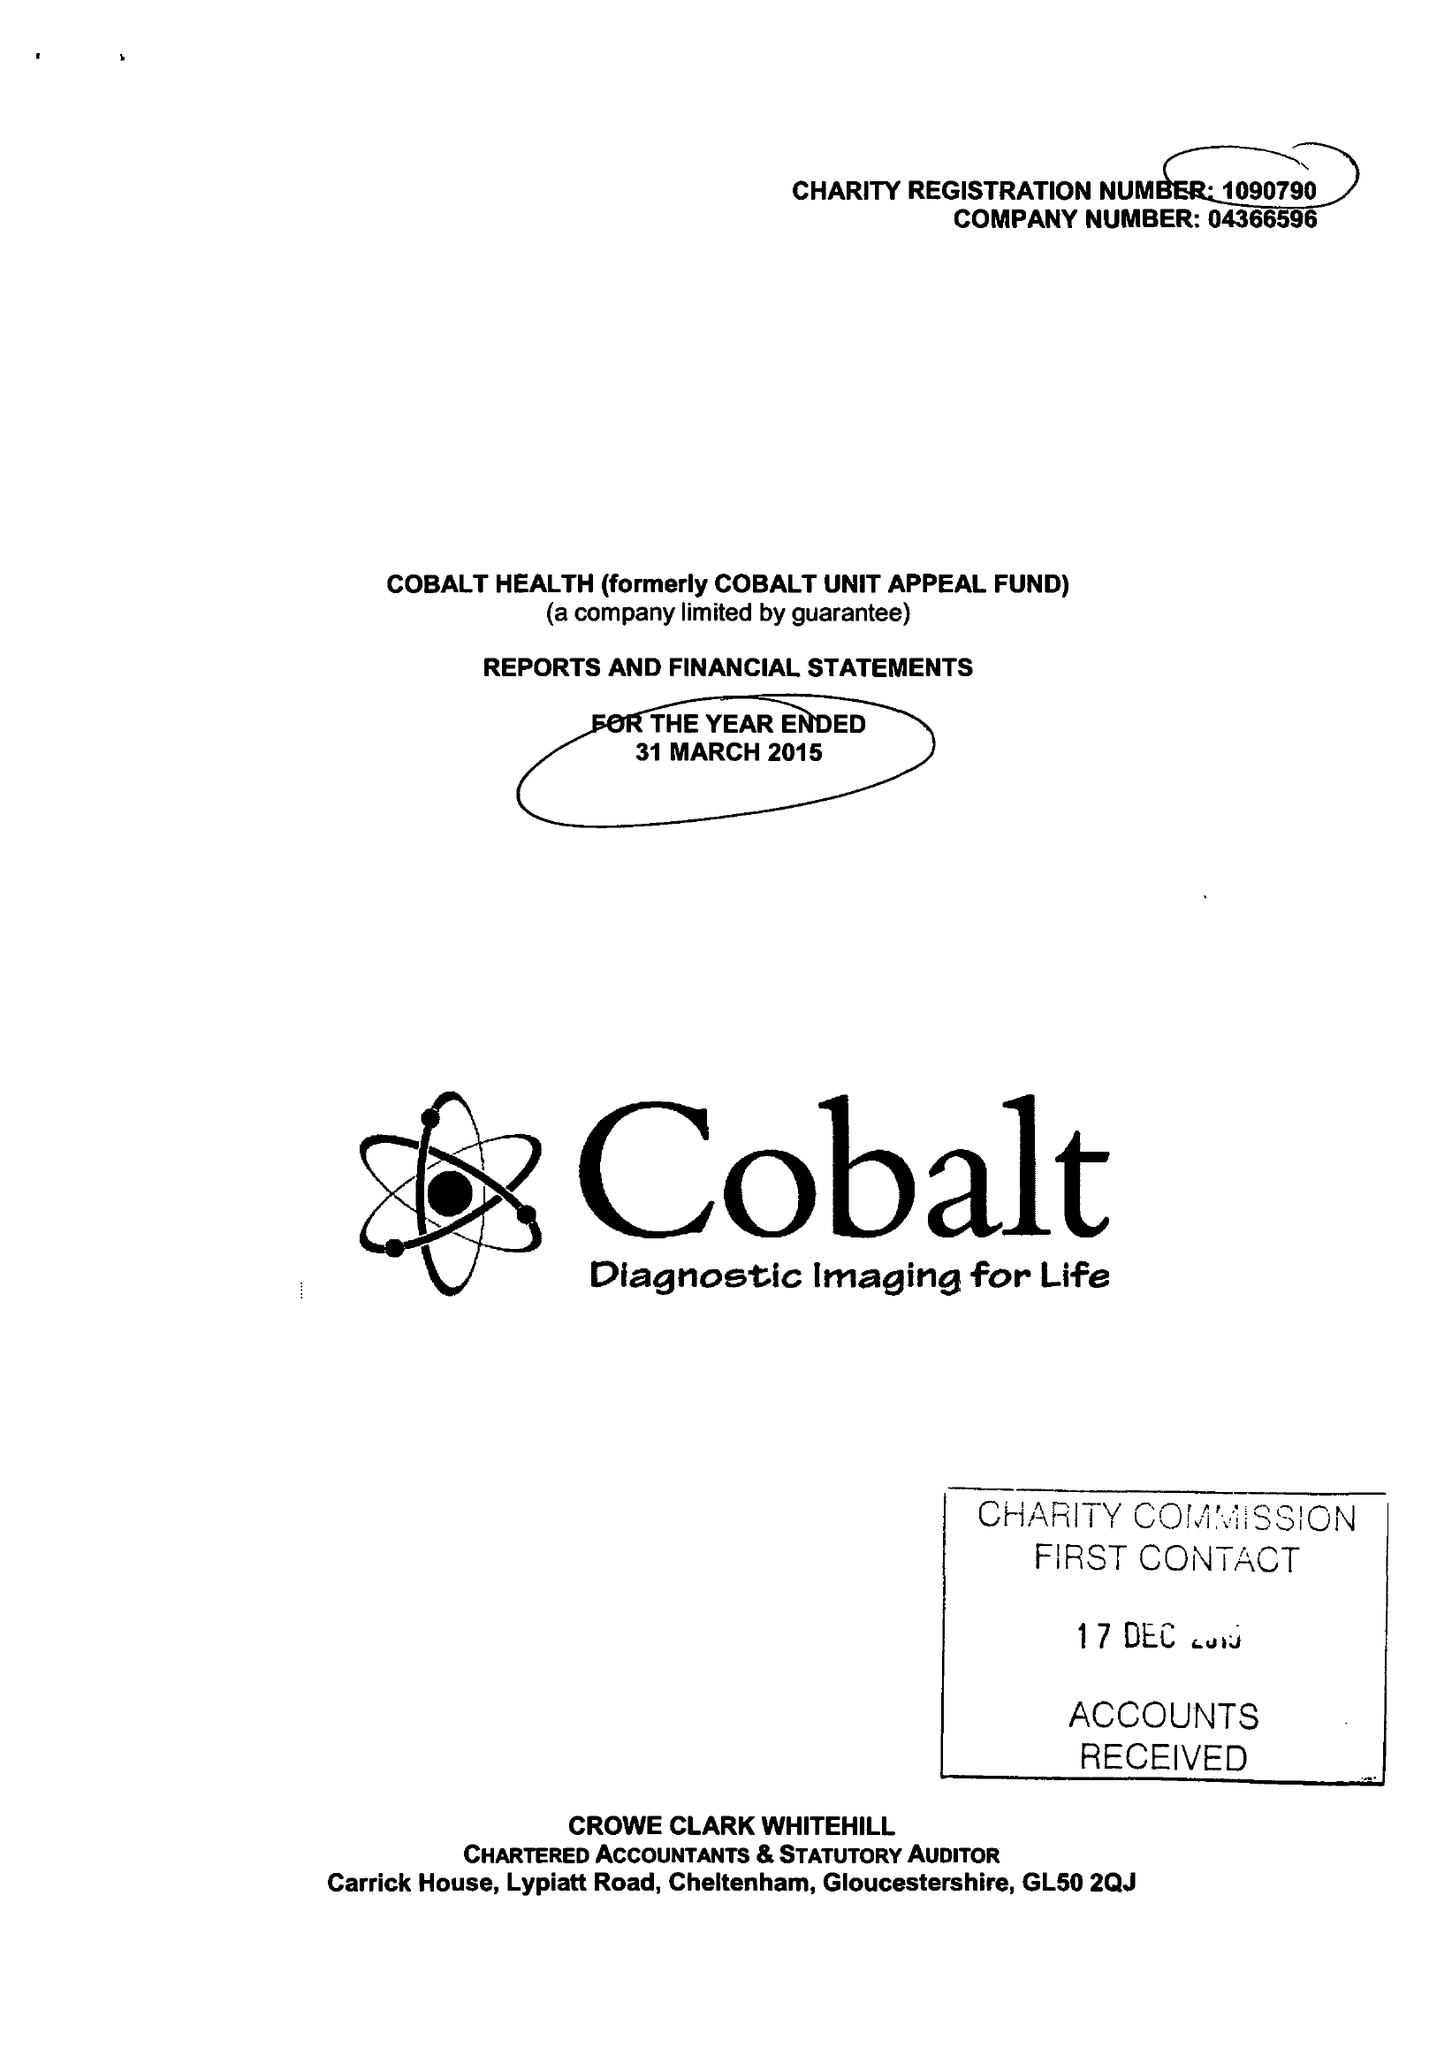What is the value for the charity_number?
Answer the question using a single word or phrase. 1090790 